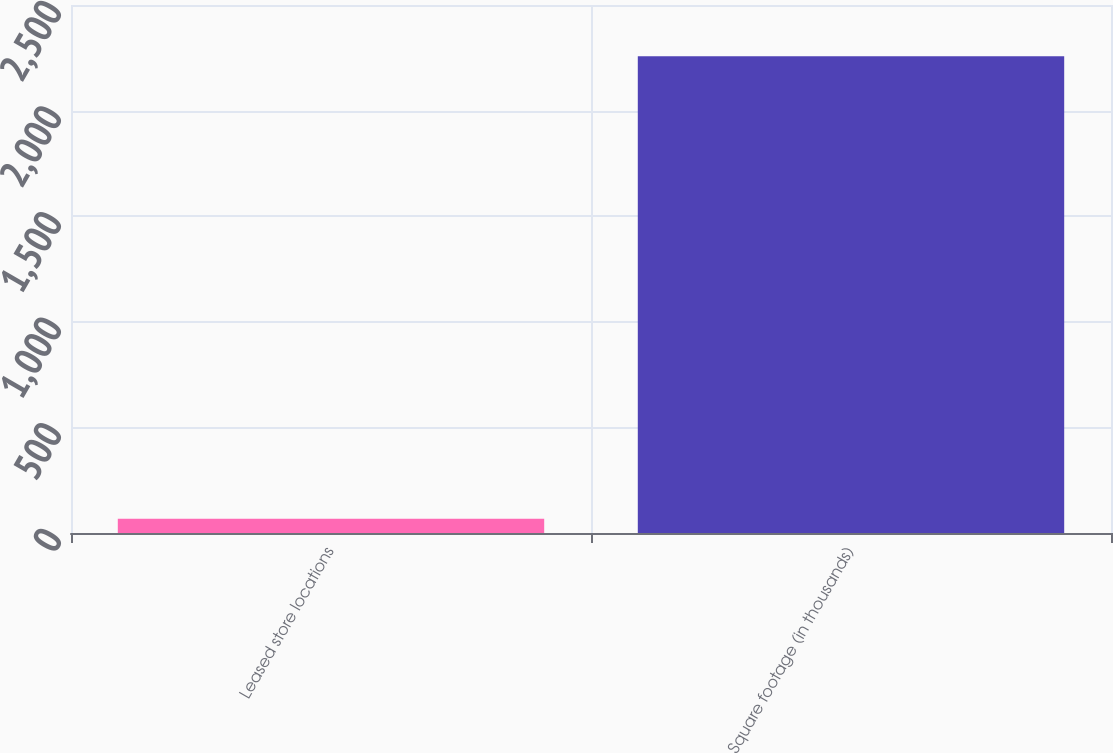Convert chart to OTSL. <chart><loc_0><loc_0><loc_500><loc_500><bar_chart><fcel>Leased store locations<fcel>Square footage (in thousands)<nl><fcel>68<fcel>2257<nl></chart> 